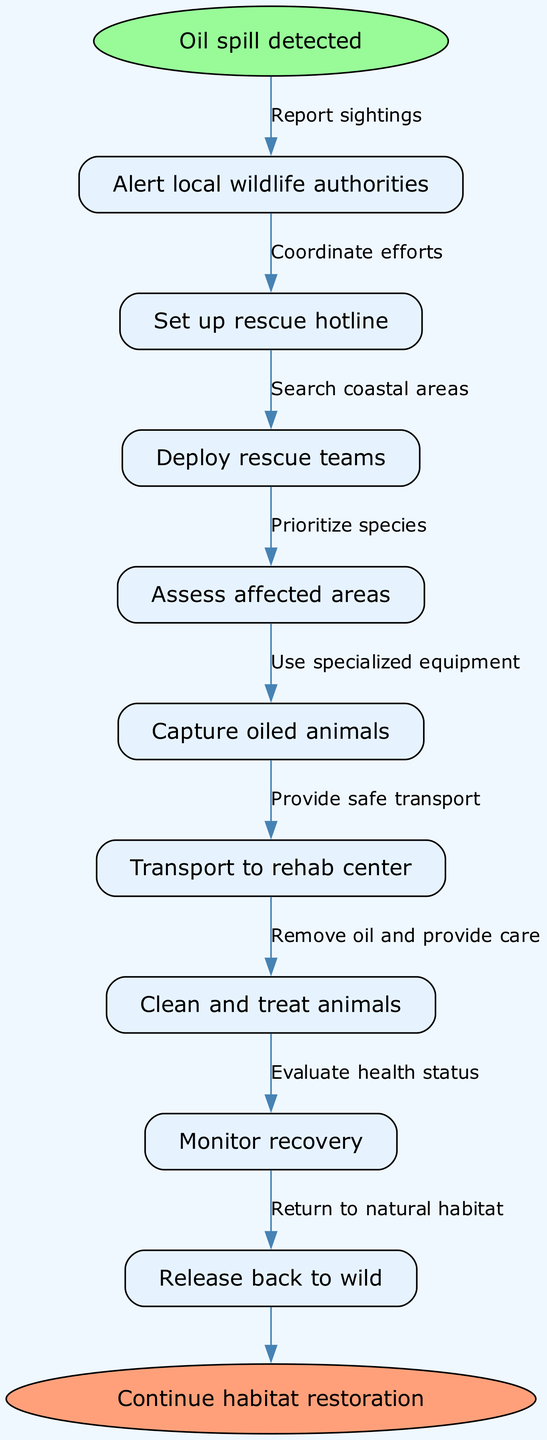What is the starting point of the procedure? The diagram shows "Oil spill detected" as the starting point, which is clearly labeled as the first node in the flow.
Answer: Oil spill detected How many nodes are there in the diagram? The diagram contains a total of 9 nodes, including the start and end points, as indicated by the listed procedures and actions.
Answer: 9 What action follows "Alert local wildlife authorities"? The flow shows that the next action after alerting the authorities is setting up a rescue hotline, connected by an edge labeled "Report sightings."
Answer: Set up rescue hotline What is the final step in the procedure? The last node in the diagram is "Continue habitat restoration," which is reached after all rescue and rehabilitation actions have been completed.
Answer: Continue habitat restoration Which two actions are directly connected by the edge labeled “Coordinate efforts”? The edge labeled “Coordinate efforts” connects "Set up rescue hotline" and "Deploy rescue teams," indicating these steps are interrelated in the procedure.
Answer: Set up rescue hotline, Deploy rescue teams How many edges are there in the diagram? There are 8 edges connecting the 9 nodes, as each action in the flow corresponds to a connection showing the procedure's sequential flow.
Answer: 8 What is the step taken after "Capture oiled animals"? The procedure indicates that after capturing the oiled animals, the next step is to transport them to the rehabilitation center, connected by the edge labeled "Provide safe transport."
Answer: Transport to rehab center What action is taken before “Clean and treat animals”? The step that occurs before "Clean and treat animals" is "Transport to rehab center," as this is shown to be the preceding action in the flowchart.
Answer: Transport to rehab center What is the edge that connects "Monitor recovery" to the next action? The edge that connects "Monitor recovery" to the next action is labeled "Evaluate health status," suggesting the need for assessment after monitoring.
Answer: Evaluate health status 